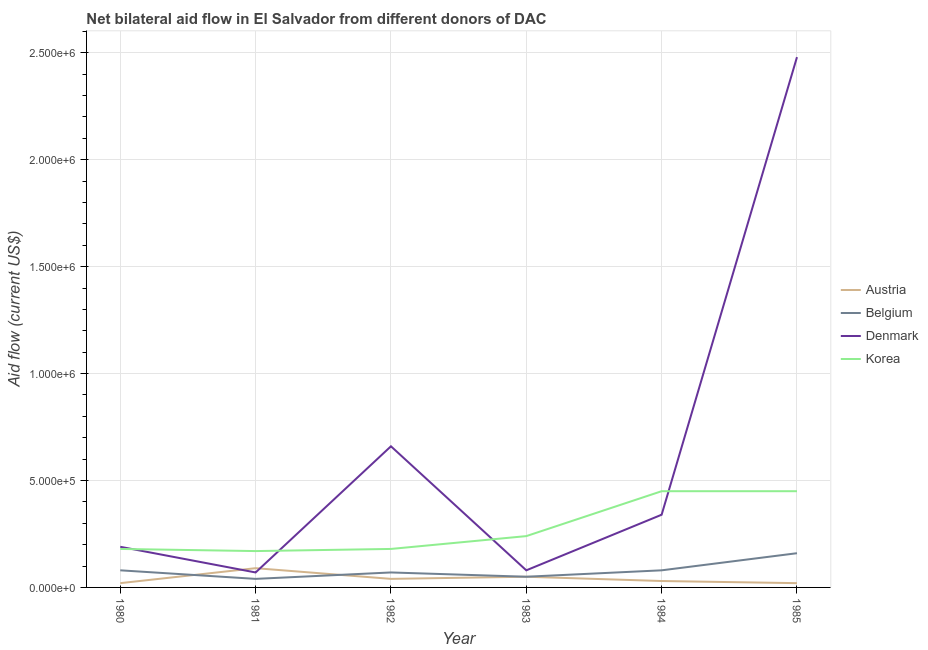Is the number of lines equal to the number of legend labels?
Offer a very short reply. Yes. What is the amount of aid given by korea in 1985?
Provide a short and direct response. 4.50e+05. Across all years, what is the maximum amount of aid given by denmark?
Offer a terse response. 2.48e+06. Across all years, what is the minimum amount of aid given by denmark?
Make the answer very short. 7.00e+04. What is the total amount of aid given by korea in the graph?
Your answer should be compact. 1.67e+06. What is the difference between the amount of aid given by denmark in 1981 and that in 1985?
Offer a terse response. -2.41e+06. What is the difference between the amount of aid given by belgium in 1985 and the amount of aid given by korea in 1983?
Your response must be concise. -8.00e+04. What is the average amount of aid given by denmark per year?
Your answer should be very brief. 6.37e+05. In the year 1985, what is the difference between the amount of aid given by denmark and amount of aid given by belgium?
Give a very brief answer. 2.32e+06. What is the difference between the highest and the lowest amount of aid given by denmark?
Provide a short and direct response. 2.41e+06. In how many years, is the amount of aid given by denmark greater than the average amount of aid given by denmark taken over all years?
Ensure brevity in your answer.  2. Is it the case that in every year, the sum of the amount of aid given by belgium and amount of aid given by denmark is greater than the sum of amount of aid given by korea and amount of aid given by austria?
Keep it short and to the point. Yes. Is it the case that in every year, the sum of the amount of aid given by austria and amount of aid given by belgium is greater than the amount of aid given by denmark?
Your answer should be compact. No. Is the amount of aid given by denmark strictly greater than the amount of aid given by austria over the years?
Provide a short and direct response. No. Is the amount of aid given by korea strictly less than the amount of aid given by belgium over the years?
Offer a terse response. No. How many legend labels are there?
Your response must be concise. 4. How are the legend labels stacked?
Make the answer very short. Vertical. What is the title of the graph?
Provide a short and direct response. Net bilateral aid flow in El Salvador from different donors of DAC. Does "Argument" appear as one of the legend labels in the graph?
Your answer should be compact. No. What is the label or title of the X-axis?
Give a very brief answer. Year. What is the label or title of the Y-axis?
Give a very brief answer. Aid flow (current US$). What is the Aid flow (current US$) of Austria in 1980?
Your answer should be very brief. 2.00e+04. What is the Aid flow (current US$) of Korea in 1980?
Offer a terse response. 1.80e+05. What is the Aid flow (current US$) in Belgium in 1981?
Your answer should be very brief. 4.00e+04. What is the Aid flow (current US$) of Denmark in 1981?
Provide a short and direct response. 7.00e+04. What is the Aid flow (current US$) of Korea in 1981?
Give a very brief answer. 1.70e+05. What is the Aid flow (current US$) of Belgium in 1982?
Keep it short and to the point. 7.00e+04. What is the Aid flow (current US$) of Denmark in 1982?
Provide a short and direct response. 6.60e+05. What is the Aid flow (current US$) of Korea in 1982?
Ensure brevity in your answer.  1.80e+05. What is the Aid flow (current US$) of Belgium in 1983?
Keep it short and to the point. 5.00e+04. What is the Aid flow (current US$) in Korea in 1984?
Make the answer very short. 4.50e+05. What is the Aid flow (current US$) in Belgium in 1985?
Offer a terse response. 1.60e+05. What is the Aid flow (current US$) of Denmark in 1985?
Provide a succinct answer. 2.48e+06. What is the Aid flow (current US$) in Korea in 1985?
Your answer should be very brief. 4.50e+05. Across all years, what is the maximum Aid flow (current US$) of Denmark?
Provide a succinct answer. 2.48e+06. Across all years, what is the minimum Aid flow (current US$) of Belgium?
Provide a short and direct response. 4.00e+04. Across all years, what is the minimum Aid flow (current US$) in Denmark?
Your answer should be compact. 7.00e+04. Across all years, what is the minimum Aid flow (current US$) in Korea?
Offer a terse response. 1.70e+05. What is the total Aid flow (current US$) in Austria in the graph?
Ensure brevity in your answer.  2.50e+05. What is the total Aid flow (current US$) of Belgium in the graph?
Ensure brevity in your answer.  4.80e+05. What is the total Aid flow (current US$) in Denmark in the graph?
Keep it short and to the point. 3.82e+06. What is the total Aid flow (current US$) in Korea in the graph?
Offer a terse response. 1.67e+06. What is the difference between the Aid flow (current US$) of Austria in 1980 and that in 1981?
Provide a succinct answer. -7.00e+04. What is the difference between the Aid flow (current US$) in Denmark in 1980 and that in 1981?
Provide a short and direct response. 1.20e+05. What is the difference between the Aid flow (current US$) of Korea in 1980 and that in 1981?
Offer a very short reply. 10000. What is the difference between the Aid flow (current US$) in Belgium in 1980 and that in 1982?
Make the answer very short. 10000. What is the difference between the Aid flow (current US$) of Denmark in 1980 and that in 1982?
Your answer should be very brief. -4.70e+05. What is the difference between the Aid flow (current US$) in Austria in 1980 and that in 1983?
Your answer should be compact. -3.00e+04. What is the difference between the Aid flow (current US$) in Korea in 1980 and that in 1983?
Keep it short and to the point. -6.00e+04. What is the difference between the Aid flow (current US$) in Denmark in 1980 and that in 1984?
Ensure brevity in your answer.  -1.50e+05. What is the difference between the Aid flow (current US$) of Austria in 1980 and that in 1985?
Ensure brevity in your answer.  0. What is the difference between the Aid flow (current US$) in Denmark in 1980 and that in 1985?
Offer a terse response. -2.29e+06. What is the difference between the Aid flow (current US$) of Austria in 1981 and that in 1982?
Give a very brief answer. 5.00e+04. What is the difference between the Aid flow (current US$) of Belgium in 1981 and that in 1982?
Ensure brevity in your answer.  -3.00e+04. What is the difference between the Aid flow (current US$) in Denmark in 1981 and that in 1982?
Provide a succinct answer. -5.90e+05. What is the difference between the Aid flow (current US$) in Austria in 1981 and that in 1983?
Make the answer very short. 4.00e+04. What is the difference between the Aid flow (current US$) in Denmark in 1981 and that in 1983?
Provide a succinct answer. -10000. What is the difference between the Aid flow (current US$) of Denmark in 1981 and that in 1984?
Provide a short and direct response. -2.70e+05. What is the difference between the Aid flow (current US$) in Korea in 1981 and that in 1984?
Offer a very short reply. -2.80e+05. What is the difference between the Aid flow (current US$) in Austria in 1981 and that in 1985?
Make the answer very short. 7.00e+04. What is the difference between the Aid flow (current US$) of Denmark in 1981 and that in 1985?
Provide a short and direct response. -2.41e+06. What is the difference between the Aid flow (current US$) in Korea in 1981 and that in 1985?
Keep it short and to the point. -2.80e+05. What is the difference between the Aid flow (current US$) of Belgium in 1982 and that in 1983?
Your answer should be compact. 2.00e+04. What is the difference between the Aid flow (current US$) of Denmark in 1982 and that in 1983?
Offer a very short reply. 5.80e+05. What is the difference between the Aid flow (current US$) of Korea in 1982 and that in 1983?
Your answer should be very brief. -6.00e+04. What is the difference between the Aid flow (current US$) of Austria in 1982 and that in 1984?
Give a very brief answer. 10000. What is the difference between the Aid flow (current US$) of Belgium in 1982 and that in 1985?
Keep it short and to the point. -9.00e+04. What is the difference between the Aid flow (current US$) of Denmark in 1982 and that in 1985?
Ensure brevity in your answer.  -1.82e+06. What is the difference between the Aid flow (current US$) in Austria in 1983 and that in 1984?
Give a very brief answer. 2.00e+04. What is the difference between the Aid flow (current US$) of Korea in 1983 and that in 1984?
Make the answer very short. -2.10e+05. What is the difference between the Aid flow (current US$) of Austria in 1983 and that in 1985?
Offer a very short reply. 3.00e+04. What is the difference between the Aid flow (current US$) in Denmark in 1983 and that in 1985?
Offer a terse response. -2.40e+06. What is the difference between the Aid flow (current US$) in Korea in 1983 and that in 1985?
Offer a terse response. -2.10e+05. What is the difference between the Aid flow (current US$) of Belgium in 1984 and that in 1985?
Your answer should be compact. -8.00e+04. What is the difference between the Aid flow (current US$) in Denmark in 1984 and that in 1985?
Ensure brevity in your answer.  -2.14e+06. What is the difference between the Aid flow (current US$) in Austria in 1980 and the Aid flow (current US$) in Korea in 1981?
Ensure brevity in your answer.  -1.50e+05. What is the difference between the Aid flow (current US$) of Belgium in 1980 and the Aid flow (current US$) of Denmark in 1981?
Ensure brevity in your answer.  10000. What is the difference between the Aid flow (current US$) of Belgium in 1980 and the Aid flow (current US$) of Korea in 1981?
Offer a very short reply. -9.00e+04. What is the difference between the Aid flow (current US$) of Austria in 1980 and the Aid flow (current US$) of Belgium in 1982?
Give a very brief answer. -5.00e+04. What is the difference between the Aid flow (current US$) in Austria in 1980 and the Aid flow (current US$) in Denmark in 1982?
Offer a terse response. -6.40e+05. What is the difference between the Aid flow (current US$) of Austria in 1980 and the Aid flow (current US$) of Korea in 1982?
Your answer should be compact. -1.60e+05. What is the difference between the Aid flow (current US$) in Belgium in 1980 and the Aid flow (current US$) in Denmark in 1982?
Your answer should be compact. -5.80e+05. What is the difference between the Aid flow (current US$) of Austria in 1980 and the Aid flow (current US$) of Korea in 1983?
Give a very brief answer. -2.20e+05. What is the difference between the Aid flow (current US$) of Belgium in 1980 and the Aid flow (current US$) of Korea in 1983?
Offer a very short reply. -1.60e+05. What is the difference between the Aid flow (current US$) in Denmark in 1980 and the Aid flow (current US$) in Korea in 1983?
Your answer should be very brief. -5.00e+04. What is the difference between the Aid flow (current US$) in Austria in 1980 and the Aid flow (current US$) in Belgium in 1984?
Keep it short and to the point. -6.00e+04. What is the difference between the Aid flow (current US$) of Austria in 1980 and the Aid flow (current US$) of Denmark in 1984?
Provide a short and direct response. -3.20e+05. What is the difference between the Aid flow (current US$) of Austria in 1980 and the Aid flow (current US$) of Korea in 1984?
Your answer should be compact. -4.30e+05. What is the difference between the Aid flow (current US$) of Belgium in 1980 and the Aid flow (current US$) of Denmark in 1984?
Offer a terse response. -2.60e+05. What is the difference between the Aid flow (current US$) in Belgium in 1980 and the Aid flow (current US$) in Korea in 1984?
Offer a terse response. -3.70e+05. What is the difference between the Aid flow (current US$) in Denmark in 1980 and the Aid flow (current US$) in Korea in 1984?
Provide a succinct answer. -2.60e+05. What is the difference between the Aid flow (current US$) of Austria in 1980 and the Aid flow (current US$) of Denmark in 1985?
Make the answer very short. -2.46e+06. What is the difference between the Aid flow (current US$) in Austria in 1980 and the Aid flow (current US$) in Korea in 1985?
Offer a very short reply. -4.30e+05. What is the difference between the Aid flow (current US$) of Belgium in 1980 and the Aid flow (current US$) of Denmark in 1985?
Your answer should be compact. -2.40e+06. What is the difference between the Aid flow (current US$) of Belgium in 1980 and the Aid flow (current US$) of Korea in 1985?
Ensure brevity in your answer.  -3.70e+05. What is the difference between the Aid flow (current US$) in Denmark in 1980 and the Aid flow (current US$) in Korea in 1985?
Make the answer very short. -2.60e+05. What is the difference between the Aid flow (current US$) of Austria in 1981 and the Aid flow (current US$) of Belgium in 1982?
Provide a succinct answer. 2.00e+04. What is the difference between the Aid flow (current US$) in Austria in 1981 and the Aid flow (current US$) in Denmark in 1982?
Provide a succinct answer. -5.70e+05. What is the difference between the Aid flow (current US$) in Austria in 1981 and the Aid flow (current US$) in Korea in 1982?
Offer a very short reply. -9.00e+04. What is the difference between the Aid flow (current US$) of Belgium in 1981 and the Aid flow (current US$) of Denmark in 1982?
Offer a very short reply. -6.20e+05. What is the difference between the Aid flow (current US$) of Belgium in 1981 and the Aid flow (current US$) of Korea in 1982?
Make the answer very short. -1.40e+05. What is the difference between the Aid flow (current US$) of Denmark in 1981 and the Aid flow (current US$) of Korea in 1982?
Offer a very short reply. -1.10e+05. What is the difference between the Aid flow (current US$) of Austria in 1981 and the Aid flow (current US$) of Belgium in 1983?
Keep it short and to the point. 4.00e+04. What is the difference between the Aid flow (current US$) of Austria in 1981 and the Aid flow (current US$) of Denmark in 1983?
Give a very brief answer. 10000. What is the difference between the Aid flow (current US$) of Austria in 1981 and the Aid flow (current US$) of Korea in 1983?
Your answer should be compact. -1.50e+05. What is the difference between the Aid flow (current US$) in Belgium in 1981 and the Aid flow (current US$) in Denmark in 1983?
Keep it short and to the point. -4.00e+04. What is the difference between the Aid flow (current US$) of Denmark in 1981 and the Aid flow (current US$) of Korea in 1983?
Provide a succinct answer. -1.70e+05. What is the difference between the Aid flow (current US$) of Austria in 1981 and the Aid flow (current US$) of Belgium in 1984?
Your answer should be compact. 10000. What is the difference between the Aid flow (current US$) of Austria in 1981 and the Aid flow (current US$) of Korea in 1984?
Your answer should be compact. -3.60e+05. What is the difference between the Aid flow (current US$) of Belgium in 1981 and the Aid flow (current US$) of Korea in 1984?
Provide a succinct answer. -4.10e+05. What is the difference between the Aid flow (current US$) of Denmark in 1981 and the Aid flow (current US$) of Korea in 1984?
Keep it short and to the point. -3.80e+05. What is the difference between the Aid flow (current US$) in Austria in 1981 and the Aid flow (current US$) in Denmark in 1985?
Give a very brief answer. -2.39e+06. What is the difference between the Aid flow (current US$) of Austria in 1981 and the Aid flow (current US$) of Korea in 1985?
Give a very brief answer. -3.60e+05. What is the difference between the Aid flow (current US$) of Belgium in 1981 and the Aid flow (current US$) of Denmark in 1985?
Give a very brief answer. -2.44e+06. What is the difference between the Aid flow (current US$) of Belgium in 1981 and the Aid flow (current US$) of Korea in 1985?
Provide a short and direct response. -4.10e+05. What is the difference between the Aid flow (current US$) of Denmark in 1981 and the Aid flow (current US$) of Korea in 1985?
Provide a short and direct response. -3.80e+05. What is the difference between the Aid flow (current US$) of Austria in 1982 and the Aid flow (current US$) of Belgium in 1983?
Offer a very short reply. -10000. What is the difference between the Aid flow (current US$) in Austria in 1982 and the Aid flow (current US$) in Denmark in 1983?
Offer a very short reply. -4.00e+04. What is the difference between the Aid flow (current US$) of Belgium in 1982 and the Aid flow (current US$) of Denmark in 1983?
Your answer should be compact. -10000. What is the difference between the Aid flow (current US$) of Belgium in 1982 and the Aid flow (current US$) of Korea in 1983?
Keep it short and to the point. -1.70e+05. What is the difference between the Aid flow (current US$) in Denmark in 1982 and the Aid flow (current US$) in Korea in 1983?
Keep it short and to the point. 4.20e+05. What is the difference between the Aid flow (current US$) in Austria in 1982 and the Aid flow (current US$) in Belgium in 1984?
Provide a succinct answer. -4.00e+04. What is the difference between the Aid flow (current US$) in Austria in 1982 and the Aid flow (current US$) in Korea in 1984?
Your answer should be very brief. -4.10e+05. What is the difference between the Aid flow (current US$) of Belgium in 1982 and the Aid flow (current US$) of Denmark in 1984?
Your answer should be very brief. -2.70e+05. What is the difference between the Aid flow (current US$) of Belgium in 1982 and the Aid flow (current US$) of Korea in 1984?
Give a very brief answer. -3.80e+05. What is the difference between the Aid flow (current US$) in Denmark in 1982 and the Aid flow (current US$) in Korea in 1984?
Your answer should be compact. 2.10e+05. What is the difference between the Aid flow (current US$) of Austria in 1982 and the Aid flow (current US$) of Belgium in 1985?
Offer a terse response. -1.20e+05. What is the difference between the Aid flow (current US$) in Austria in 1982 and the Aid flow (current US$) in Denmark in 1985?
Provide a succinct answer. -2.44e+06. What is the difference between the Aid flow (current US$) of Austria in 1982 and the Aid flow (current US$) of Korea in 1985?
Give a very brief answer. -4.10e+05. What is the difference between the Aid flow (current US$) of Belgium in 1982 and the Aid flow (current US$) of Denmark in 1985?
Provide a succinct answer. -2.41e+06. What is the difference between the Aid flow (current US$) in Belgium in 1982 and the Aid flow (current US$) in Korea in 1985?
Make the answer very short. -3.80e+05. What is the difference between the Aid flow (current US$) in Denmark in 1982 and the Aid flow (current US$) in Korea in 1985?
Your response must be concise. 2.10e+05. What is the difference between the Aid flow (current US$) of Austria in 1983 and the Aid flow (current US$) of Belgium in 1984?
Your answer should be very brief. -3.00e+04. What is the difference between the Aid flow (current US$) of Austria in 1983 and the Aid flow (current US$) of Denmark in 1984?
Ensure brevity in your answer.  -2.90e+05. What is the difference between the Aid flow (current US$) of Austria in 1983 and the Aid flow (current US$) of Korea in 1984?
Give a very brief answer. -4.00e+05. What is the difference between the Aid flow (current US$) of Belgium in 1983 and the Aid flow (current US$) of Korea in 1984?
Provide a short and direct response. -4.00e+05. What is the difference between the Aid flow (current US$) in Denmark in 1983 and the Aid flow (current US$) in Korea in 1984?
Your response must be concise. -3.70e+05. What is the difference between the Aid flow (current US$) of Austria in 1983 and the Aid flow (current US$) of Denmark in 1985?
Provide a short and direct response. -2.43e+06. What is the difference between the Aid flow (current US$) of Austria in 1983 and the Aid flow (current US$) of Korea in 1985?
Your answer should be very brief. -4.00e+05. What is the difference between the Aid flow (current US$) of Belgium in 1983 and the Aid flow (current US$) of Denmark in 1985?
Provide a short and direct response. -2.43e+06. What is the difference between the Aid flow (current US$) in Belgium in 1983 and the Aid flow (current US$) in Korea in 1985?
Offer a very short reply. -4.00e+05. What is the difference between the Aid flow (current US$) of Denmark in 1983 and the Aid flow (current US$) of Korea in 1985?
Your response must be concise. -3.70e+05. What is the difference between the Aid flow (current US$) of Austria in 1984 and the Aid flow (current US$) of Belgium in 1985?
Give a very brief answer. -1.30e+05. What is the difference between the Aid flow (current US$) of Austria in 1984 and the Aid flow (current US$) of Denmark in 1985?
Your answer should be compact. -2.45e+06. What is the difference between the Aid flow (current US$) of Austria in 1984 and the Aid flow (current US$) of Korea in 1985?
Ensure brevity in your answer.  -4.20e+05. What is the difference between the Aid flow (current US$) of Belgium in 1984 and the Aid flow (current US$) of Denmark in 1985?
Provide a succinct answer. -2.40e+06. What is the difference between the Aid flow (current US$) of Belgium in 1984 and the Aid flow (current US$) of Korea in 1985?
Your response must be concise. -3.70e+05. What is the average Aid flow (current US$) of Austria per year?
Keep it short and to the point. 4.17e+04. What is the average Aid flow (current US$) in Denmark per year?
Your answer should be compact. 6.37e+05. What is the average Aid flow (current US$) in Korea per year?
Ensure brevity in your answer.  2.78e+05. In the year 1980, what is the difference between the Aid flow (current US$) in Austria and Aid flow (current US$) in Denmark?
Offer a very short reply. -1.70e+05. In the year 1980, what is the difference between the Aid flow (current US$) in Belgium and Aid flow (current US$) in Denmark?
Offer a terse response. -1.10e+05. In the year 1981, what is the difference between the Aid flow (current US$) in Austria and Aid flow (current US$) in Belgium?
Give a very brief answer. 5.00e+04. In the year 1981, what is the difference between the Aid flow (current US$) of Austria and Aid flow (current US$) of Korea?
Offer a terse response. -8.00e+04. In the year 1981, what is the difference between the Aid flow (current US$) of Belgium and Aid flow (current US$) of Denmark?
Give a very brief answer. -3.00e+04. In the year 1981, what is the difference between the Aid flow (current US$) of Belgium and Aid flow (current US$) of Korea?
Provide a succinct answer. -1.30e+05. In the year 1982, what is the difference between the Aid flow (current US$) in Austria and Aid flow (current US$) in Denmark?
Provide a succinct answer. -6.20e+05. In the year 1982, what is the difference between the Aid flow (current US$) in Belgium and Aid flow (current US$) in Denmark?
Your answer should be very brief. -5.90e+05. In the year 1983, what is the difference between the Aid flow (current US$) of Austria and Aid flow (current US$) of Belgium?
Provide a short and direct response. 0. In the year 1983, what is the difference between the Aid flow (current US$) of Belgium and Aid flow (current US$) of Denmark?
Offer a terse response. -3.00e+04. In the year 1983, what is the difference between the Aid flow (current US$) of Belgium and Aid flow (current US$) of Korea?
Your answer should be very brief. -1.90e+05. In the year 1983, what is the difference between the Aid flow (current US$) in Denmark and Aid flow (current US$) in Korea?
Offer a terse response. -1.60e+05. In the year 1984, what is the difference between the Aid flow (current US$) of Austria and Aid flow (current US$) of Belgium?
Give a very brief answer. -5.00e+04. In the year 1984, what is the difference between the Aid flow (current US$) in Austria and Aid flow (current US$) in Denmark?
Ensure brevity in your answer.  -3.10e+05. In the year 1984, what is the difference between the Aid flow (current US$) of Austria and Aid flow (current US$) of Korea?
Offer a very short reply. -4.20e+05. In the year 1984, what is the difference between the Aid flow (current US$) in Belgium and Aid flow (current US$) in Denmark?
Provide a short and direct response. -2.60e+05. In the year 1984, what is the difference between the Aid flow (current US$) in Belgium and Aid flow (current US$) in Korea?
Your answer should be compact. -3.70e+05. In the year 1985, what is the difference between the Aid flow (current US$) of Austria and Aid flow (current US$) of Belgium?
Offer a very short reply. -1.40e+05. In the year 1985, what is the difference between the Aid flow (current US$) of Austria and Aid flow (current US$) of Denmark?
Make the answer very short. -2.46e+06. In the year 1985, what is the difference between the Aid flow (current US$) of Austria and Aid flow (current US$) of Korea?
Offer a very short reply. -4.30e+05. In the year 1985, what is the difference between the Aid flow (current US$) of Belgium and Aid flow (current US$) of Denmark?
Make the answer very short. -2.32e+06. In the year 1985, what is the difference between the Aid flow (current US$) in Denmark and Aid flow (current US$) in Korea?
Your answer should be very brief. 2.03e+06. What is the ratio of the Aid flow (current US$) of Austria in 1980 to that in 1981?
Your answer should be very brief. 0.22. What is the ratio of the Aid flow (current US$) in Belgium in 1980 to that in 1981?
Your answer should be very brief. 2. What is the ratio of the Aid flow (current US$) of Denmark in 1980 to that in 1981?
Your answer should be compact. 2.71. What is the ratio of the Aid flow (current US$) of Korea in 1980 to that in 1981?
Make the answer very short. 1.06. What is the ratio of the Aid flow (current US$) of Belgium in 1980 to that in 1982?
Offer a very short reply. 1.14. What is the ratio of the Aid flow (current US$) in Denmark in 1980 to that in 1982?
Offer a very short reply. 0.29. What is the ratio of the Aid flow (current US$) in Austria in 1980 to that in 1983?
Keep it short and to the point. 0.4. What is the ratio of the Aid flow (current US$) of Belgium in 1980 to that in 1983?
Offer a very short reply. 1.6. What is the ratio of the Aid flow (current US$) in Denmark in 1980 to that in 1983?
Keep it short and to the point. 2.38. What is the ratio of the Aid flow (current US$) of Korea in 1980 to that in 1983?
Your answer should be compact. 0.75. What is the ratio of the Aid flow (current US$) of Denmark in 1980 to that in 1984?
Offer a terse response. 0.56. What is the ratio of the Aid flow (current US$) of Korea in 1980 to that in 1984?
Your answer should be compact. 0.4. What is the ratio of the Aid flow (current US$) of Austria in 1980 to that in 1985?
Provide a succinct answer. 1. What is the ratio of the Aid flow (current US$) in Denmark in 1980 to that in 1985?
Your answer should be very brief. 0.08. What is the ratio of the Aid flow (current US$) in Korea in 1980 to that in 1985?
Provide a short and direct response. 0.4. What is the ratio of the Aid flow (current US$) in Austria in 1981 to that in 1982?
Offer a very short reply. 2.25. What is the ratio of the Aid flow (current US$) in Belgium in 1981 to that in 1982?
Offer a very short reply. 0.57. What is the ratio of the Aid flow (current US$) in Denmark in 1981 to that in 1982?
Offer a very short reply. 0.11. What is the ratio of the Aid flow (current US$) of Korea in 1981 to that in 1982?
Provide a short and direct response. 0.94. What is the ratio of the Aid flow (current US$) of Austria in 1981 to that in 1983?
Make the answer very short. 1.8. What is the ratio of the Aid flow (current US$) of Korea in 1981 to that in 1983?
Your answer should be very brief. 0.71. What is the ratio of the Aid flow (current US$) in Belgium in 1981 to that in 1984?
Provide a succinct answer. 0.5. What is the ratio of the Aid flow (current US$) in Denmark in 1981 to that in 1984?
Your answer should be very brief. 0.21. What is the ratio of the Aid flow (current US$) of Korea in 1981 to that in 1984?
Keep it short and to the point. 0.38. What is the ratio of the Aid flow (current US$) of Austria in 1981 to that in 1985?
Provide a succinct answer. 4.5. What is the ratio of the Aid flow (current US$) in Denmark in 1981 to that in 1985?
Provide a short and direct response. 0.03. What is the ratio of the Aid flow (current US$) in Korea in 1981 to that in 1985?
Ensure brevity in your answer.  0.38. What is the ratio of the Aid flow (current US$) of Austria in 1982 to that in 1983?
Keep it short and to the point. 0.8. What is the ratio of the Aid flow (current US$) of Belgium in 1982 to that in 1983?
Your answer should be compact. 1.4. What is the ratio of the Aid flow (current US$) of Denmark in 1982 to that in 1983?
Keep it short and to the point. 8.25. What is the ratio of the Aid flow (current US$) in Korea in 1982 to that in 1983?
Make the answer very short. 0.75. What is the ratio of the Aid flow (current US$) of Austria in 1982 to that in 1984?
Offer a terse response. 1.33. What is the ratio of the Aid flow (current US$) in Belgium in 1982 to that in 1984?
Ensure brevity in your answer.  0.88. What is the ratio of the Aid flow (current US$) of Denmark in 1982 to that in 1984?
Make the answer very short. 1.94. What is the ratio of the Aid flow (current US$) in Korea in 1982 to that in 1984?
Keep it short and to the point. 0.4. What is the ratio of the Aid flow (current US$) in Belgium in 1982 to that in 1985?
Ensure brevity in your answer.  0.44. What is the ratio of the Aid flow (current US$) in Denmark in 1982 to that in 1985?
Provide a succinct answer. 0.27. What is the ratio of the Aid flow (current US$) of Austria in 1983 to that in 1984?
Your response must be concise. 1.67. What is the ratio of the Aid flow (current US$) in Belgium in 1983 to that in 1984?
Give a very brief answer. 0.62. What is the ratio of the Aid flow (current US$) of Denmark in 1983 to that in 1984?
Keep it short and to the point. 0.24. What is the ratio of the Aid flow (current US$) of Korea in 1983 to that in 1984?
Your answer should be very brief. 0.53. What is the ratio of the Aid flow (current US$) in Belgium in 1983 to that in 1985?
Give a very brief answer. 0.31. What is the ratio of the Aid flow (current US$) in Denmark in 1983 to that in 1985?
Provide a succinct answer. 0.03. What is the ratio of the Aid flow (current US$) in Korea in 1983 to that in 1985?
Ensure brevity in your answer.  0.53. What is the ratio of the Aid flow (current US$) in Austria in 1984 to that in 1985?
Provide a short and direct response. 1.5. What is the ratio of the Aid flow (current US$) of Denmark in 1984 to that in 1985?
Provide a short and direct response. 0.14. What is the ratio of the Aid flow (current US$) in Korea in 1984 to that in 1985?
Offer a very short reply. 1. What is the difference between the highest and the second highest Aid flow (current US$) in Austria?
Keep it short and to the point. 4.00e+04. What is the difference between the highest and the second highest Aid flow (current US$) of Belgium?
Ensure brevity in your answer.  8.00e+04. What is the difference between the highest and the second highest Aid flow (current US$) of Denmark?
Give a very brief answer. 1.82e+06. What is the difference between the highest and the second highest Aid flow (current US$) of Korea?
Provide a succinct answer. 0. What is the difference between the highest and the lowest Aid flow (current US$) in Belgium?
Your answer should be compact. 1.20e+05. What is the difference between the highest and the lowest Aid flow (current US$) of Denmark?
Provide a short and direct response. 2.41e+06. What is the difference between the highest and the lowest Aid flow (current US$) of Korea?
Keep it short and to the point. 2.80e+05. 